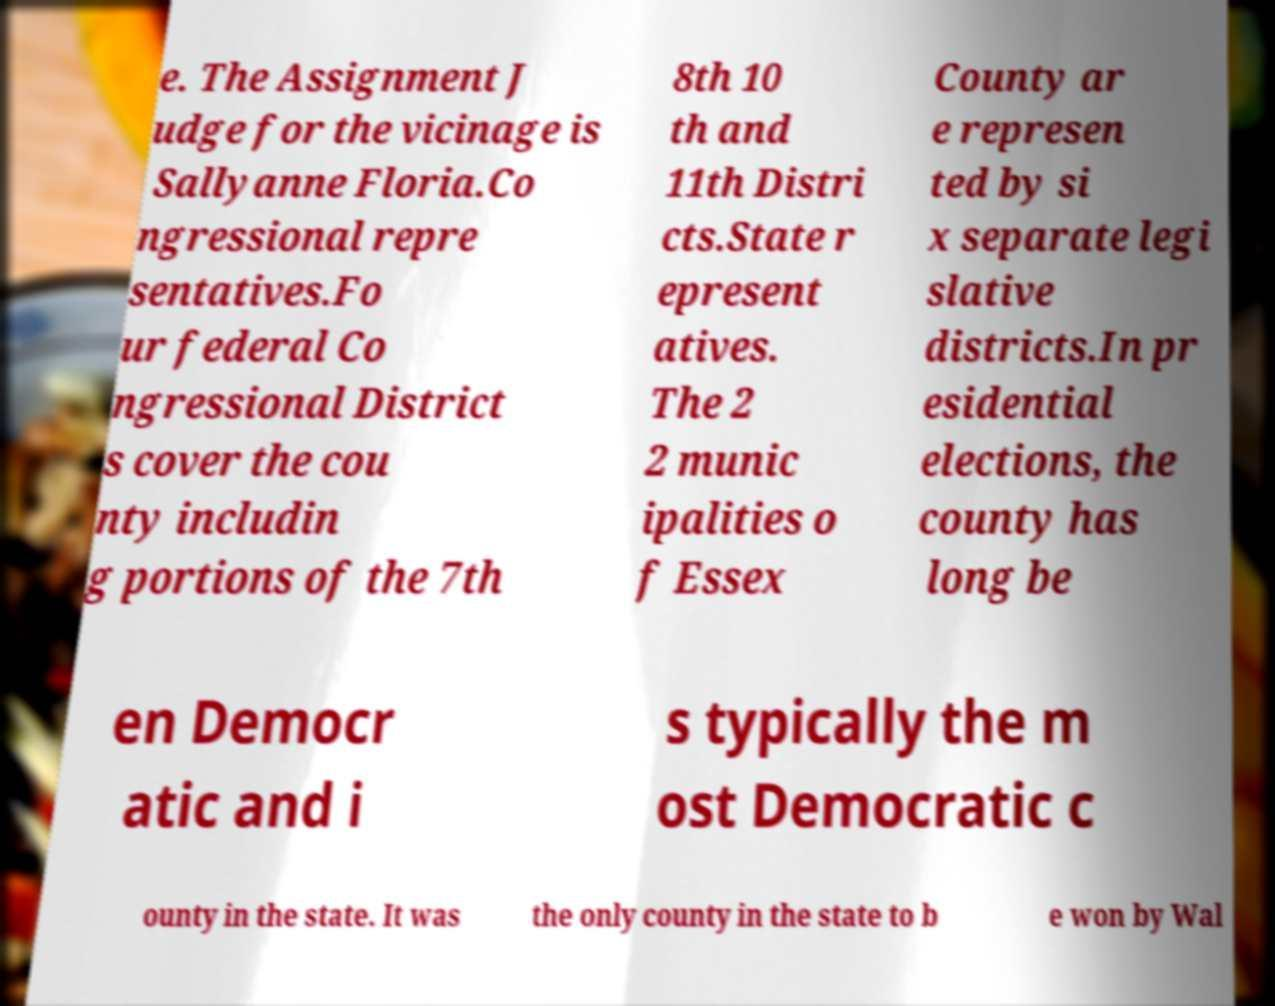Could you assist in decoding the text presented in this image and type it out clearly? e. The Assignment J udge for the vicinage is Sallyanne Floria.Co ngressional repre sentatives.Fo ur federal Co ngressional District s cover the cou nty includin g portions of the 7th 8th 10 th and 11th Distri cts.State r epresent atives. The 2 2 munic ipalities o f Essex County ar e represen ted by si x separate legi slative districts.In pr esidential elections, the county has long be en Democr atic and i s typically the m ost Democratic c ounty in the state. It was the only county in the state to b e won by Wal 